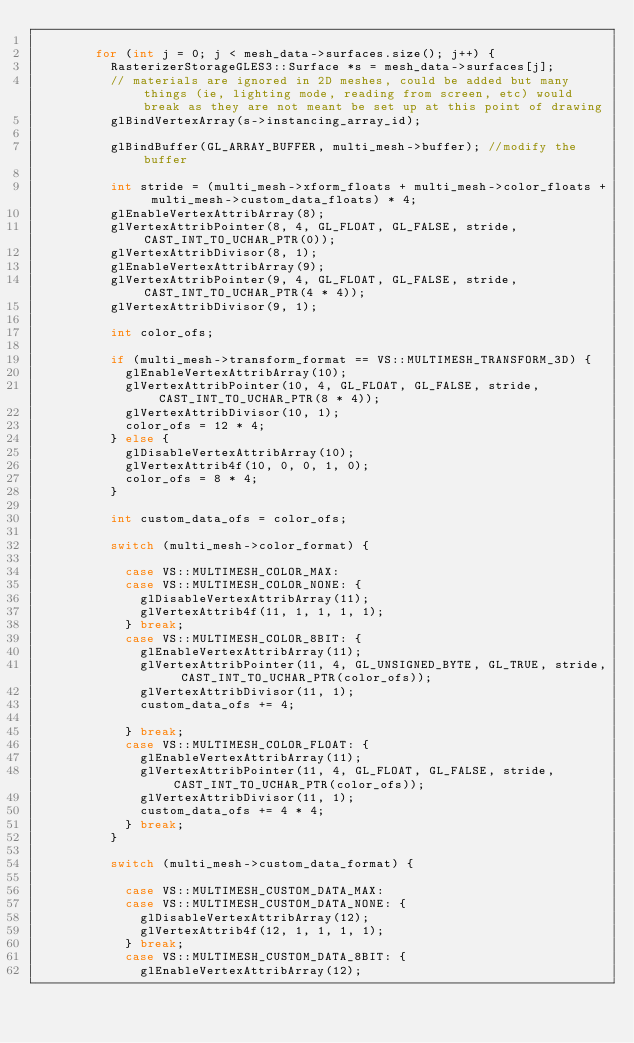Convert code to text. <code><loc_0><loc_0><loc_500><loc_500><_C++_>
				for (int j = 0; j < mesh_data->surfaces.size(); j++) {
					RasterizerStorageGLES3::Surface *s = mesh_data->surfaces[j];
					// materials are ignored in 2D meshes, could be added but many things (ie, lighting mode, reading from screen, etc) would break as they are not meant be set up at this point of drawing
					glBindVertexArray(s->instancing_array_id);

					glBindBuffer(GL_ARRAY_BUFFER, multi_mesh->buffer); //modify the buffer

					int stride = (multi_mesh->xform_floats + multi_mesh->color_floats + multi_mesh->custom_data_floats) * 4;
					glEnableVertexAttribArray(8);
					glVertexAttribPointer(8, 4, GL_FLOAT, GL_FALSE, stride, CAST_INT_TO_UCHAR_PTR(0));
					glVertexAttribDivisor(8, 1);
					glEnableVertexAttribArray(9);
					glVertexAttribPointer(9, 4, GL_FLOAT, GL_FALSE, stride, CAST_INT_TO_UCHAR_PTR(4 * 4));
					glVertexAttribDivisor(9, 1);

					int color_ofs;

					if (multi_mesh->transform_format == VS::MULTIMESH_TRANSFORM_3D) {
						glEnableVertexAttribArray(10);
						glVertexAttribPointer(10, 4, GL_FLOAT, GL_FALSE, stride, CAST_INT_TO_UCHAR_PTR(8 * 4));
						glVertexAttribDivisor(10, 1);
						color_ofs = 12 * 4;
					} else {
						glDisableVertexAttribArray(10);
						glVertexAttrib4f(10, 0, 0, 1, 0);
						color_ofs = 8 * 4;
					}

					int custom_data_ofs = color_ofs;

					switch (multi_mesh->color_format) {

						case VS::MULTIMESH_COLOR_MAX:
						case VS::MULTIMESH_COLOR_NONE: {
							glDisableVertexAttribArray(11);
							glVertexAttrib4f(11, 1, 1, 1, 1);
						} break;
						case VS::MULTIMESH_COLOR_8BIT: {
							glEnableVertexAttribArray(11);
							glVertexAttribPointer(11, 4, GL_UNSIGNED_BYTE, GL_TRUE, stride, CAST_INT_TO_UCHAR_PTR(color_ofs));
							glVertexAttribDivisor(11, 1);
							custom_data_ofs += 4;

						} break;
						case VS::MULTIMESH_COLOR_FLOAT: {
							glEnableVertexAttribArray(11);
							glVertexAttribPointer(11, 4, GL_FLOAT, GL_FALSE, stride, CAST_INT_TO_UCHAR_PTR(color_ofs));
							glVertexAttribDivisor(11, 1);
							custom_data_ofs += 4 * 4;
						} break;
					}

					switch (multi_mesh->custom_data_format) {

						case VS::MULTIMESH_CUSTOM_DATA_MAX:
						case VS::MULTIMESH_CUSTOM_DATA_NONE: {
							glDisableVertexAttribArray(12);
							glVertexAttrib4f(12, 1, 1, 1, 1);
						} break;
						case VS::MULTIMESH_CUSTOM_DATA_8BIT: {
							glEnableVertexAttribArray(12);</code> 